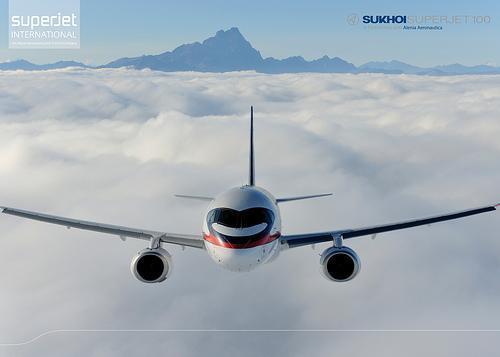How many jets are above the clouds?
Give a very brief answer. 1. 